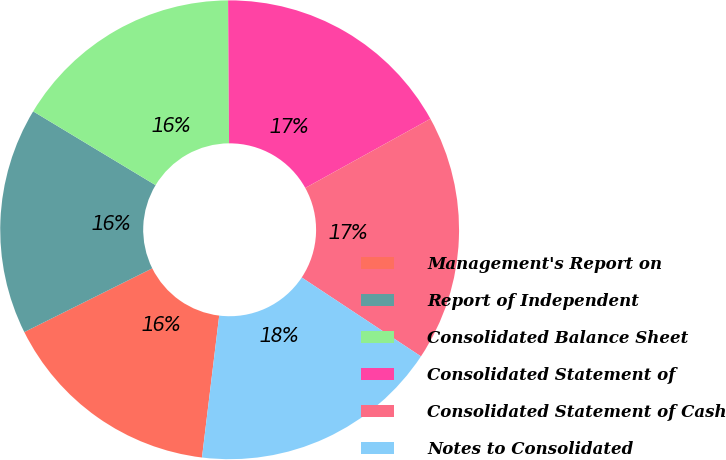Convert chart. <chart><loc_0><loc_0><loc_500><loc_500><pie_chart><fcel>Management's Report on<fcel>Report of Independent<fcel>Consolidated Balance Sheet<fcel>Consolidated Statement of<fcel>Consolidated Statement of Cash<fcel>Notes to Consolidated<nl><fcel>15.72%<fcel>15.99%<fcel>16.26%<fcel>17.07%<fcel>17.34%<fcel>17.62%<nl></chart> 